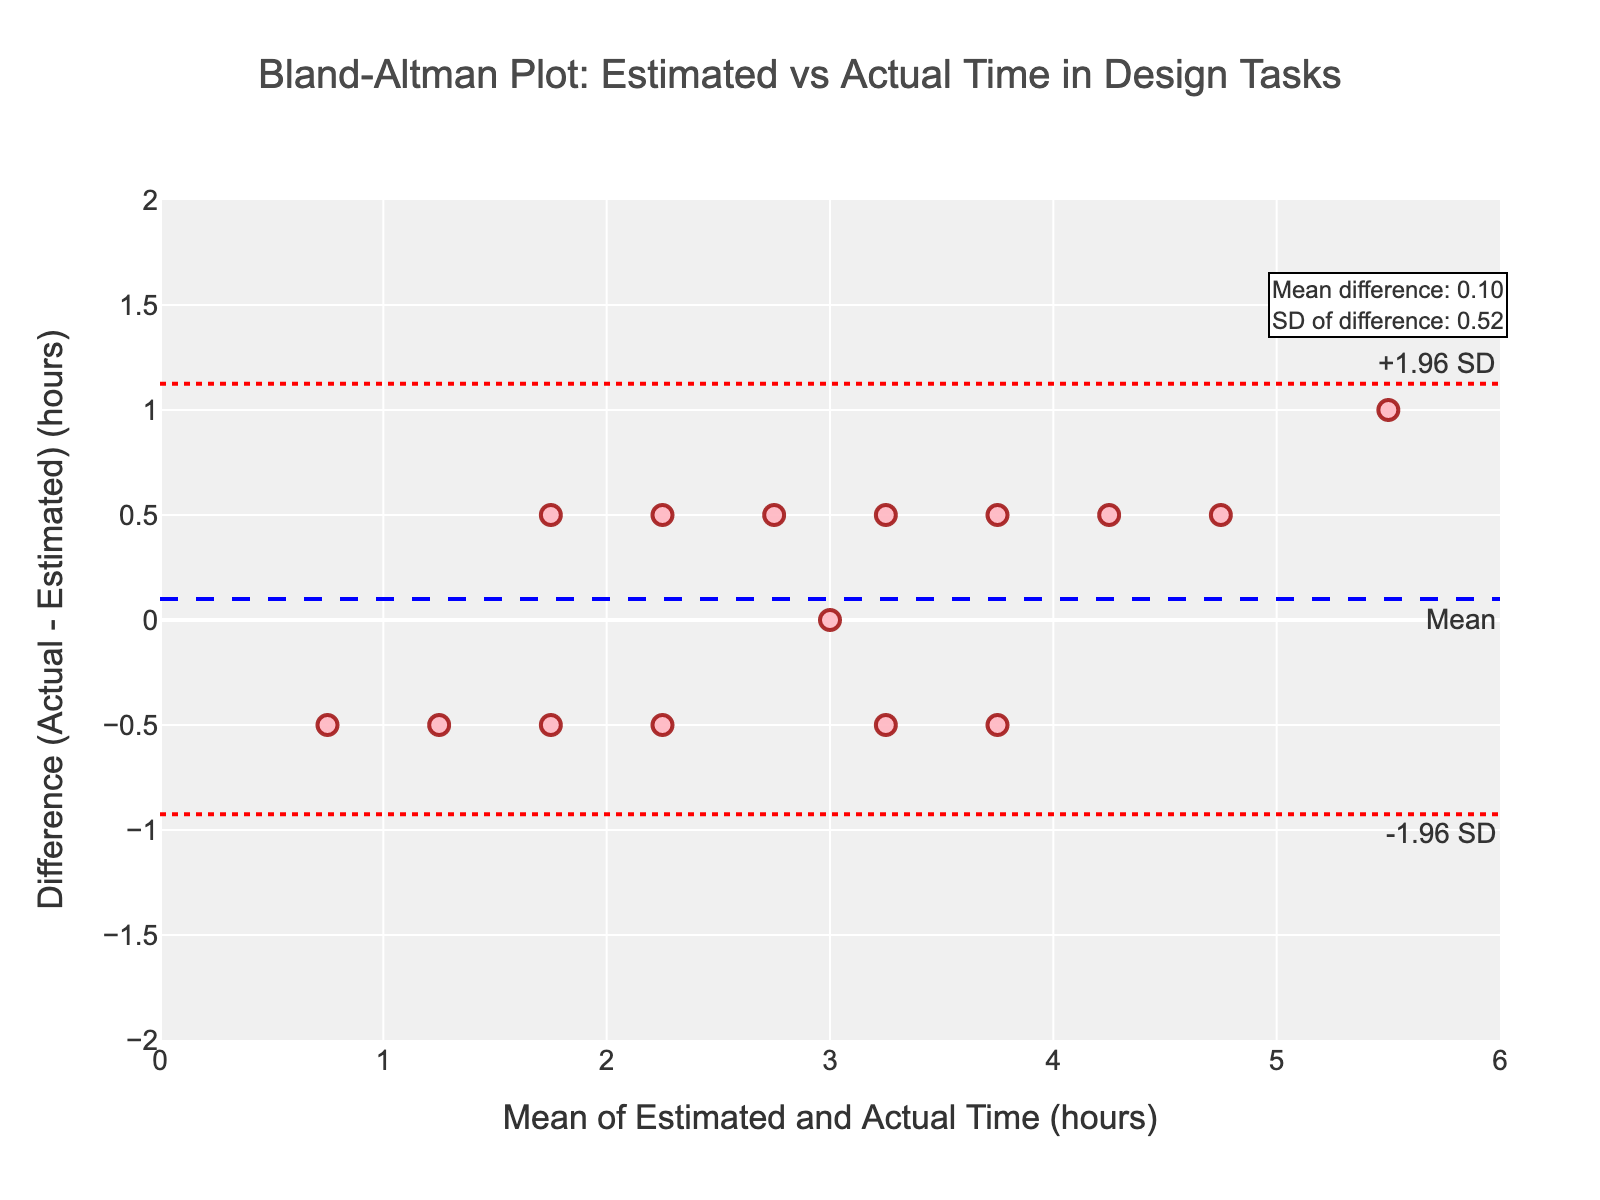What is the title of the plot? The title is prominently displayed at the top of the plot.
Answer: Bland-Altman Plot: Estimated vs Actual Time in Design Tasks What are the labels of the x-axis and y-axis? The labels are indicated on the axes.
Answer: x-axis: Mean of Estimated and Actual Time (hours), y-axis: Difference (Actual - Estimated) (hours) What is the range of the x-axis in this plot? The x-axis range is marked with ticks, and the axis itself spans from one end to the other.
Answer: 0 to 6 How many data points are shown in the plot? Each data point is marked as a scatter plot. Count all the points.
Answer: 15 What is the mean difference between actual and estimated times? The mean difference is shown as an annotated text line on the plot.
Answer: 0.27 hours What are the upper and lower limits of agreement? The upper and lower limits are represented by dotted red lines and annotated on the plot.
Answer: Upper: 1.55, Lower: -1.01 Which data point shows the largest positive difference between actual and estimated times? Look for the data point with the highest positive y-value (difference) on the scatter plot.
Answer: (5.0, 6.0) - Diff: 1.0 Are there more data points above or below the mean difference line? Visually count the data points above and below the blue mean difference line.
Answer: More points below Which data point has the mean of estimated and actual times closest to 3 hours? Identify the data point nearest to 3 on the x-axis.
Answer: (3.0, 3.5) - Mean: 3.25 What is the standard deviation of the differences? The standard deviation is provided in the annotated text on the plot.
Answer: 0.65 hours 